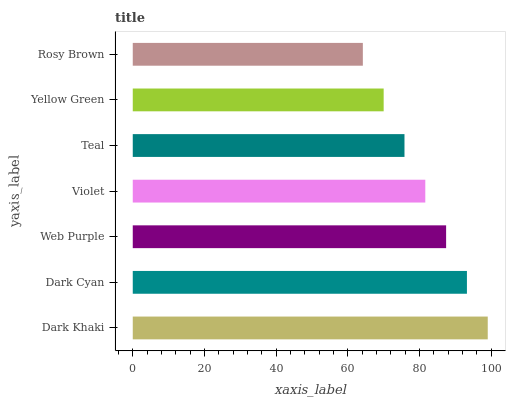Is Rosy Brown the minimum?
Answer yes or no. Yes. Is Dark Khaki the maximum?
Answer yes or no. Yes. Is Dark Cyan the minimum?
Answer yes or no. No. Is Dark Cyan the maximum?
Answer yes or no. No. Is Dark Khaki greater than Dark Cyan?
Answer yes or no. Yes. Is Dark Cyan less than Dark Khaki?
Answer yes or no. Yes. Is Dark Cyan greater than Dark Khaki?
Answer yes or no. No. Is Dark Khaki less than Dark Cyan?
Answer yes or no. No. Is Violet the high median?
Answer yes or no. Yes. Is Violet the low median?
Answer yes or no. Yes. Is Dark Cyan the high median?
Answer yes or no. No. Is Yellow Green the low median?
Answer yes or no. No. 